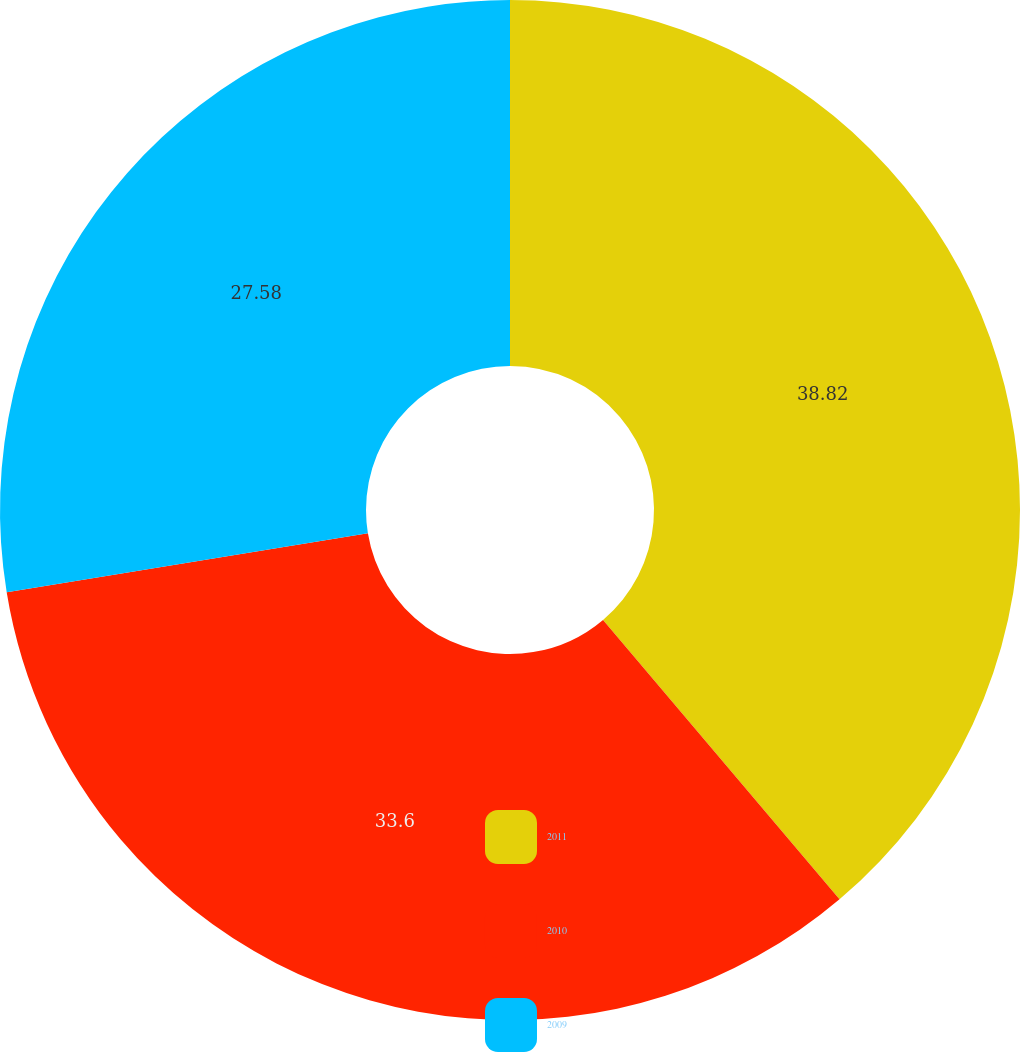Convert chart to OTSL. <chart><loc_0><loc_0><loc_500><loc_500><pie_chart><fcel>2011<fcel>2010<fcel>2009<nl><fcel>38.82%<fcel>33.6%<fcel>27.58%<nl></chart> 